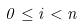<formula> <loc_0><loc_0><loc_500><loc_500>0 \leq i < n</formula> 